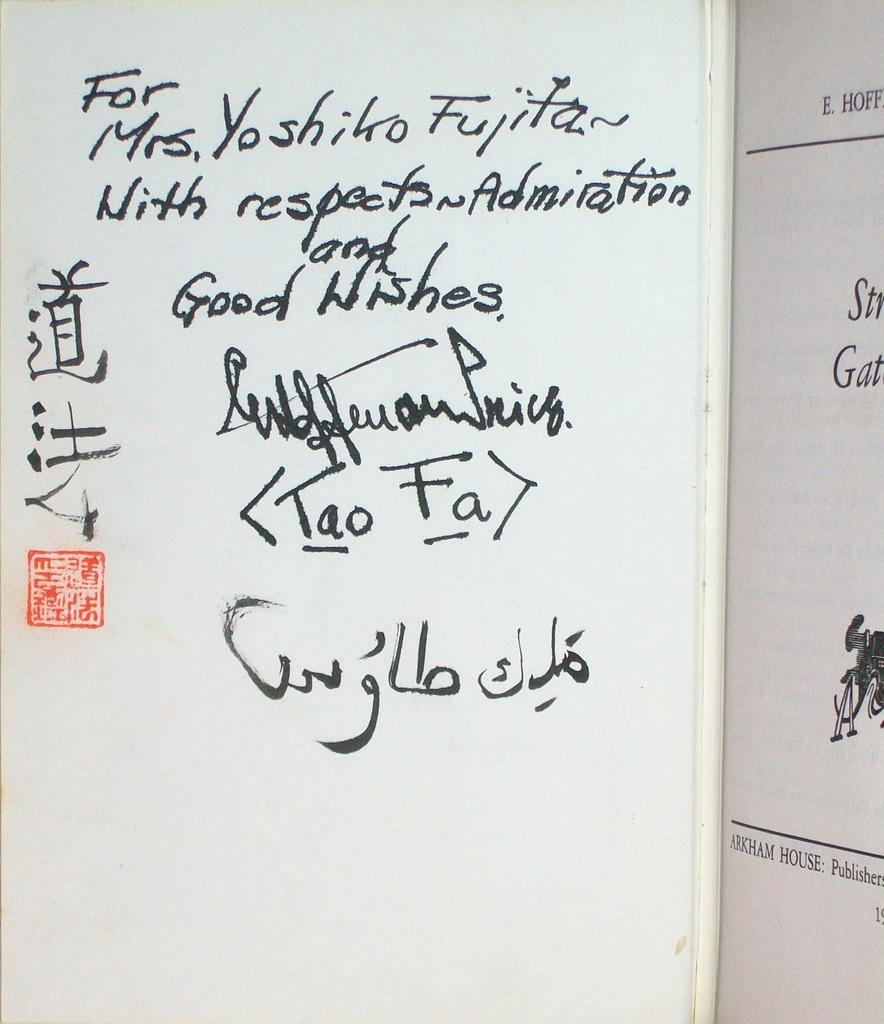Provide a one-sentence caption for the provided image. Someone has written a note to Mrs. Yoshiko Fujita in black ink. 